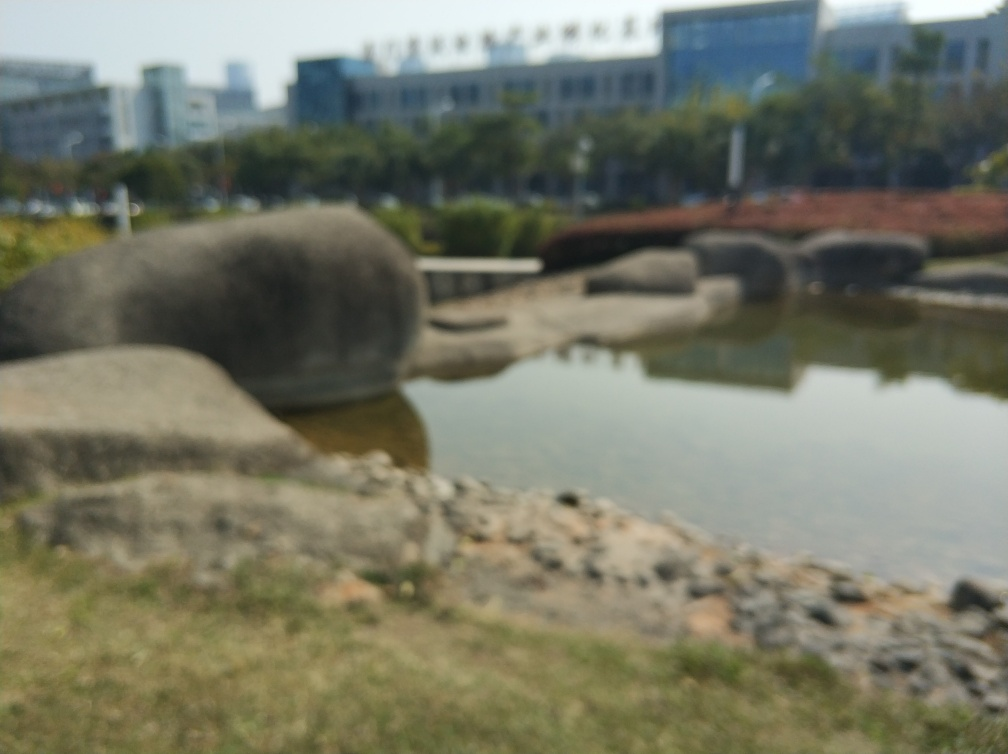Is the quality of this image poor?
 Yes 